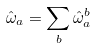<formula> <loc_0><loc_0><loc_500><loc_500>\hat { \omega } _ { a } = \sum _ { b } \hat { \omega } _ { a } ^ { b }</formula> 